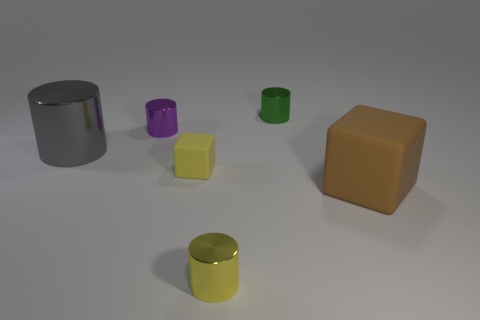Subtract 1 cylinders. How many cylinders are left? 3 Add 1 big cubes. How many objects exist? 7 Subtract all cylinders. How many objects are left? 2 Subtract 1 brown blocks. How many objects are left? 5 Subtract all large gray metal objects. Subtract all tiny metallic things. How many objects are left? 2 Add 5 matte things. How many matte things are left? 7 Add 3 big red metallic spheres. How many big red metallic spheres exist? 3 